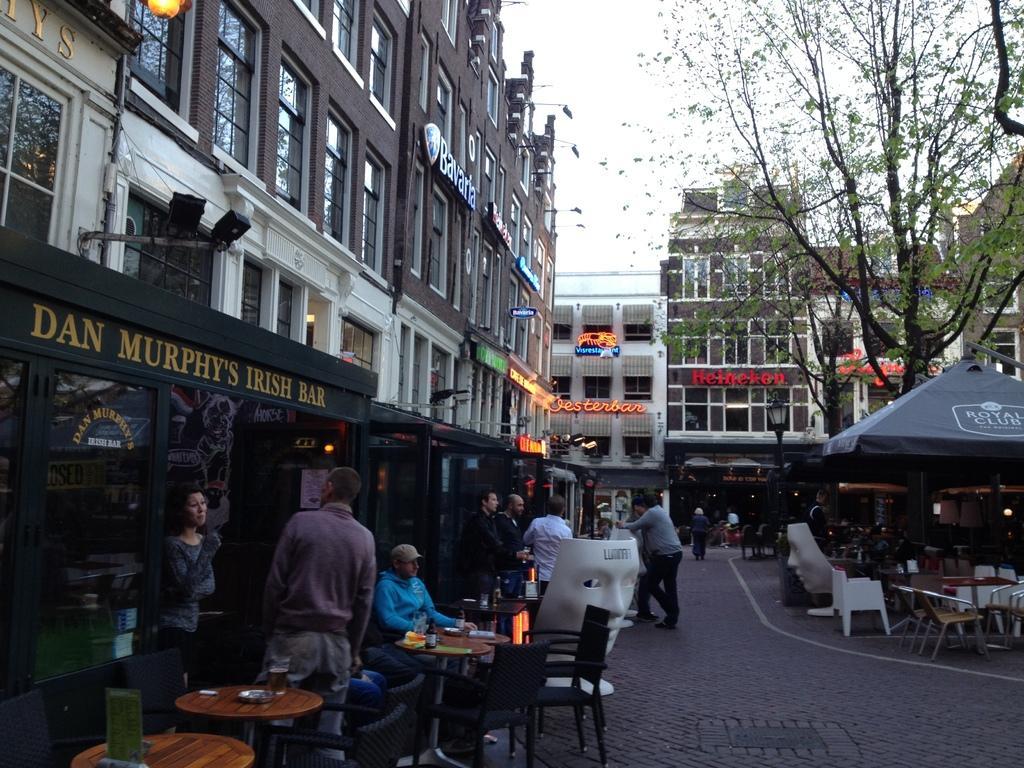Describe this image in one or two sentences. In this picture I can see there are few tables at left and right side, there are few people standing and few are sitting. There is a tree at right side and there are buildings at left and right side. 